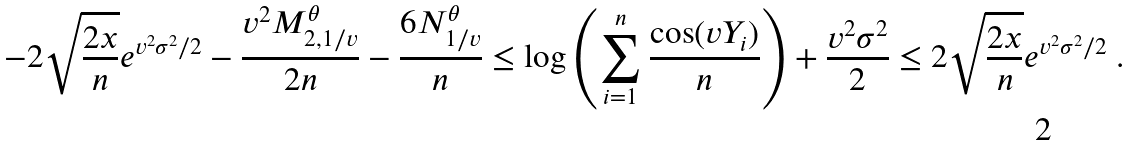Convert formula to latex. <formula><loc_0><loc_0><loc_500><loc_500>- 2 \sqrt { \frac { 2 x } { n } } e ^ { v ^ { 2 } \sigma ^ { 2 } / 2 } - \frac { v ^ { 2 } M _ { 2 , 1 / v } ^ { \theta } } { 2 n } - \frac { 6 N _ { 1 / v } ^ { \theta } } { n } \leq \log \left ( \sum _ { i = 1 } ^ { n } \frac { \cos ( v Y _ { i } ) } { n } \right ) + \frac { v ^ { 2 } \sigma ^ { 2 } } { 2 } \leq 2 \sqrt { \frac { 2 x } { n } } e ^ { v ^ { 2 } \sigma ^ { 2 } / 2 } \ .</formula> 